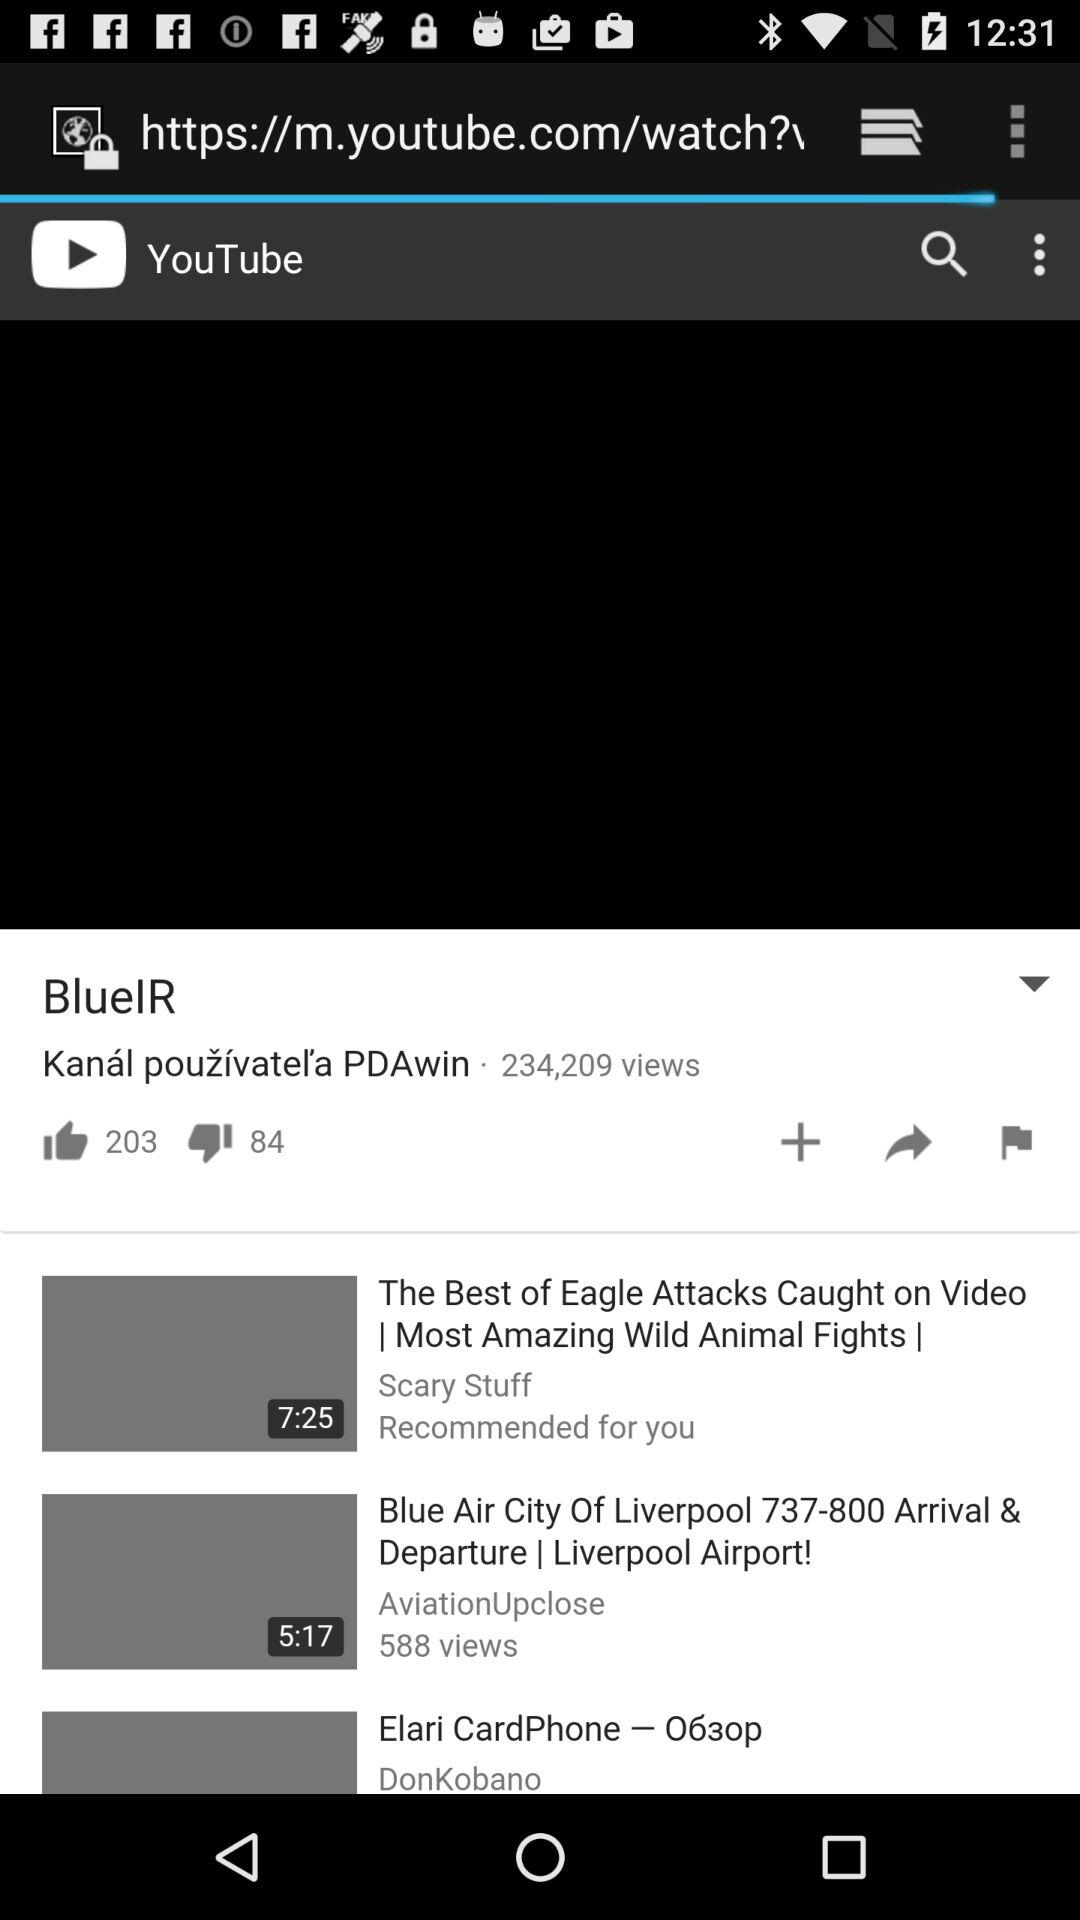What is the application name? The application name is "BlueIR". 